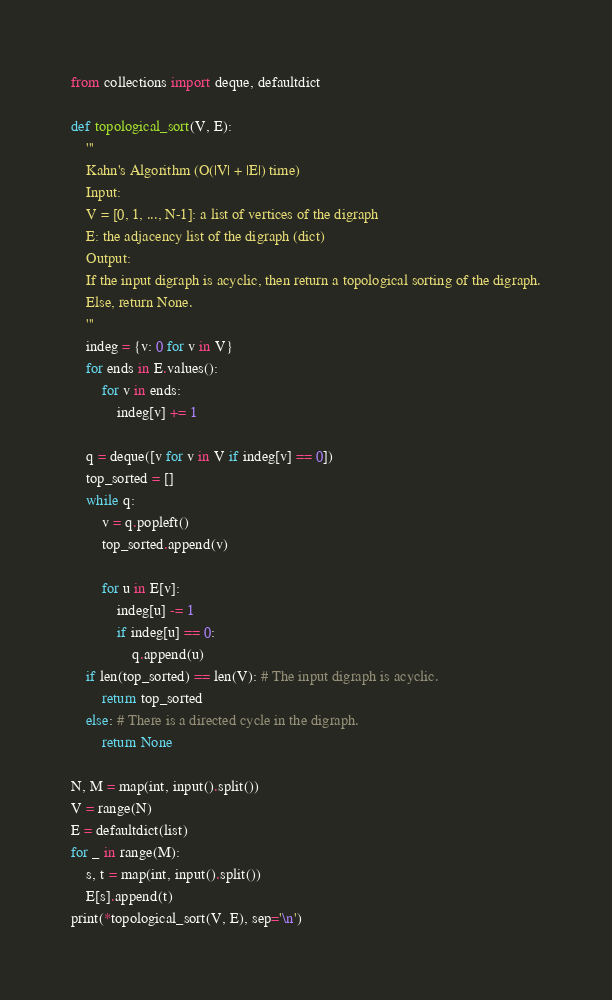Convert code to text. <code><loc_0><loc_0><loc_500><loc_500><_Python_>from collections import deque, defaultdict

def topological_sort(V, E):
    '''
    Kahn's Algorithm (O(|V| + |E|) time)
    Input:
    V = [0, 1, ..., N-1]: a list of vertices of the digraph
    E: the adjacency list of the digraph (dict)
    Output:
    If the input digraph is acyclic, then return a topological sorting of the digraph.
    Else, return None.
    '''
    indeg = {v: 0 for v in V}
    for ends in E.values():
        for v in ends:
            indeg[v] += 1
    
    q = deque([v for v in V if indeg[v] == 0])
    top_sorted = []
    while q:
        v = q.popleft()
        top_sorted.append(v)
        
        for u in E[v]:
            indeg[u] -= 1
            if indeg[u] == 0:
                q.append(u)
    if len(top_sorted) == len(V): # The input digraph is acyclic.
        return top_sorted
    else: # There is a directed cycle in the digraph.
        return None

N, M = map(int, input().split())
V = range(N)
E = defaultdict(list)
for _ in range(M):
    s, t = map(int, input().split())
    E[s].append(t)
print(*topological_sort(V, E), sep='\n')
</code> 